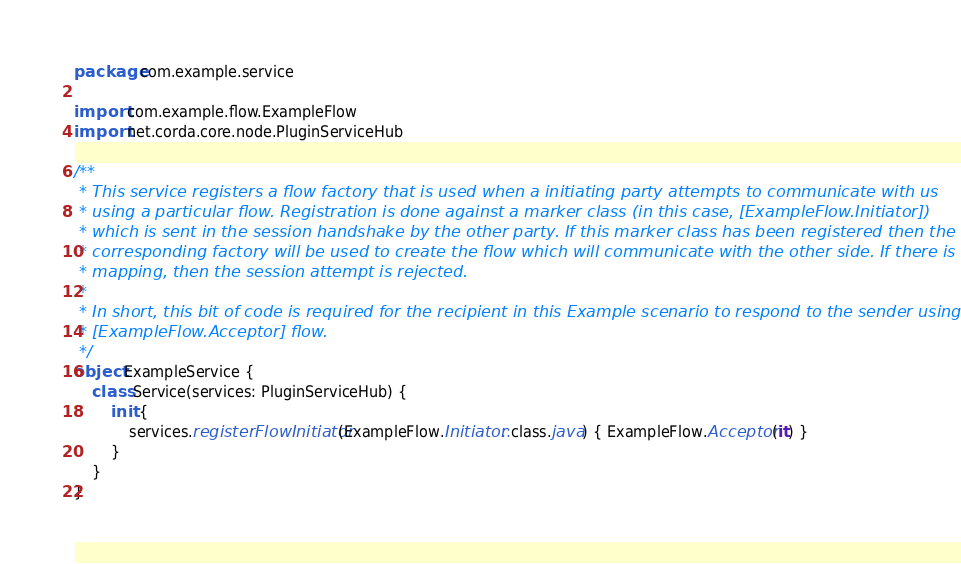<code> <loc_0><loc_0><loc_500><loc_500><_Kotlin_>package com.example.service

import com.example.flow.ExampleFlow
import net.corda.core.node.PluginServiceHub

/**
 * This service registers a flow factory that is used when a initiating party attempts to communicate with us
 * using a particular flow. Registration is done against a marker class (in this case, [ExampleFlow.Initiator])
 * which is sent in the session handshake by the other party. If this marker class has been registered then the
 * corresponding factory will be used to create the flow which will communicate with the other side. If there is no
 * mapping, then the session attempt is rejected.
 *
 * In short, this bit of code is required for the recipient in this Example scenario to respond to the sender using the
 * [ExampleFlow.Acceptor] flow.
 */
object ExampleService {
    class Service(services: PluginServiceHub) {
        init {
            services.registerFlowInitiator(ExampleFlow.Initiator::class.java) { ExampleFlow.Acceptor(it) }
        }
    }
}</code> 